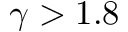Convert formula to latex. <formula><loc_0><loc_0><loc_500><loc_500>\gamma > 1 . 8</formula> 